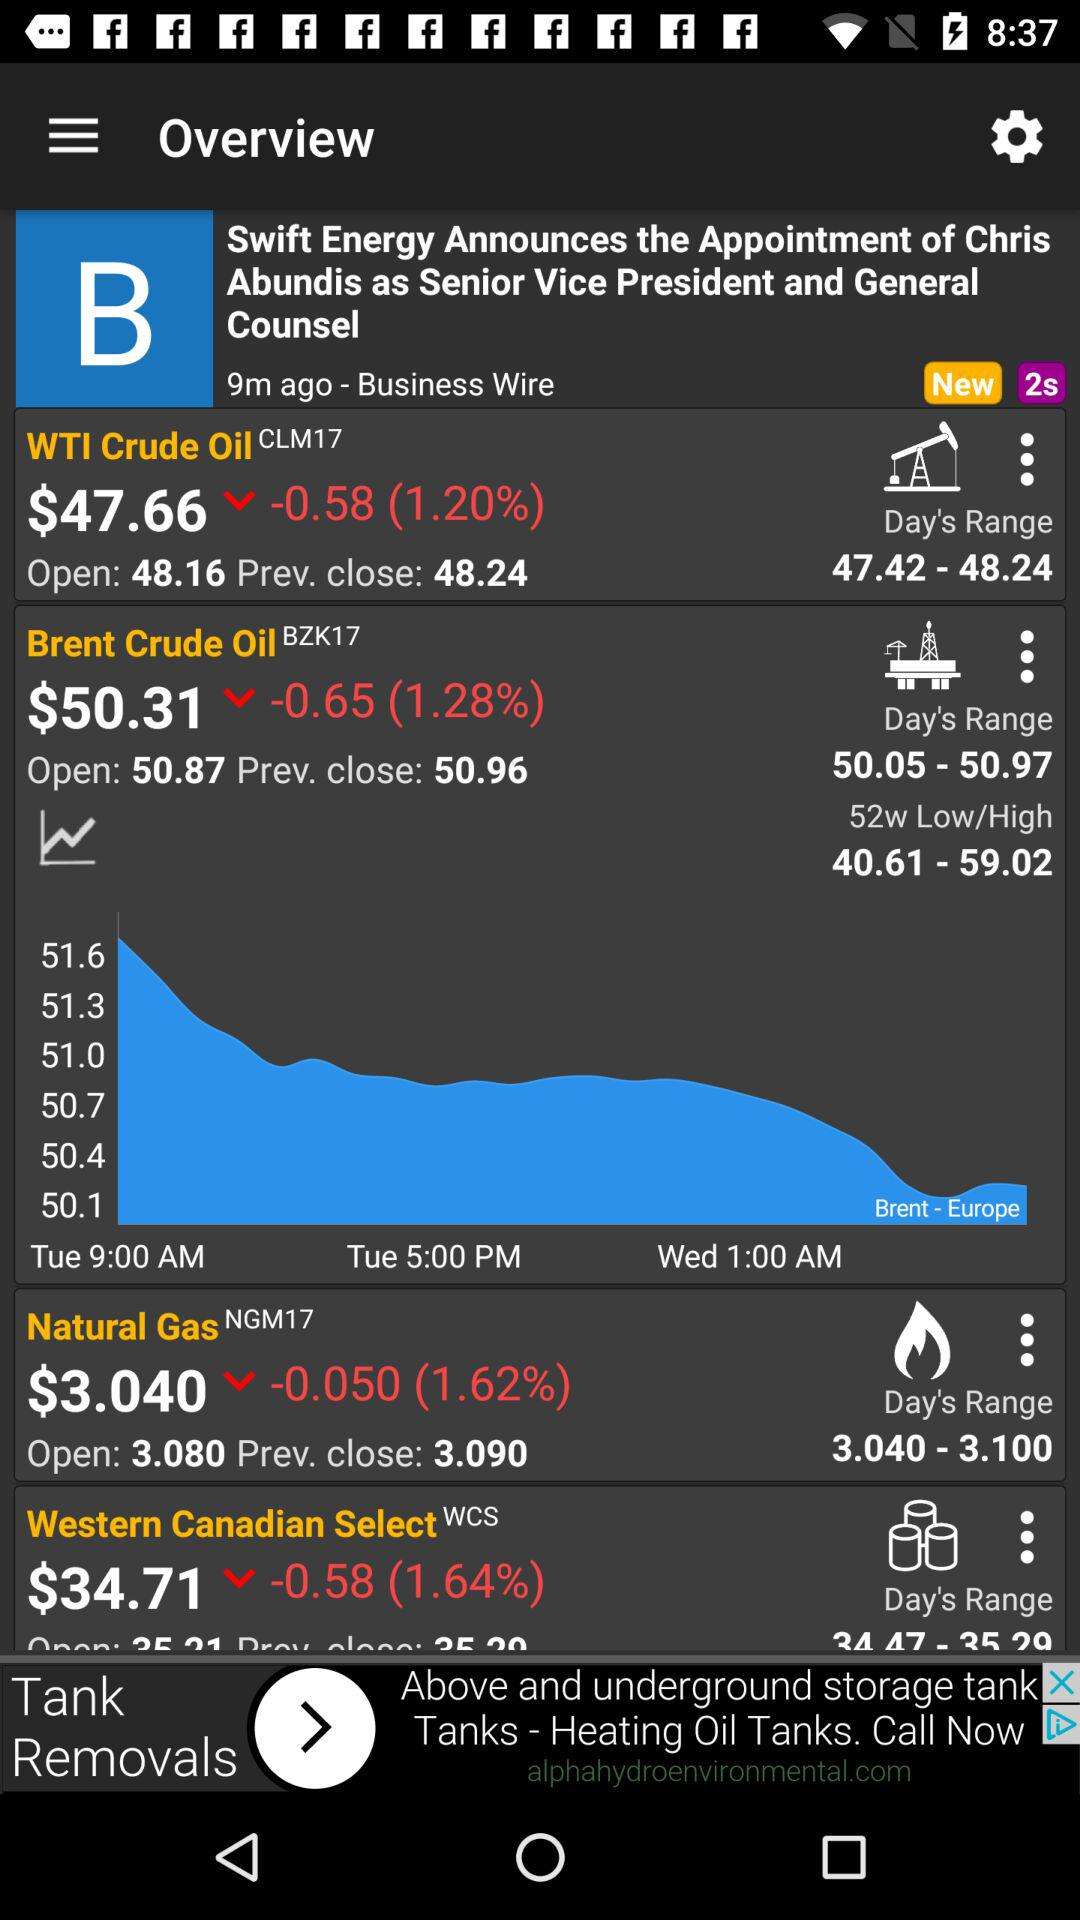What is the day's range of "Natural Gas"? The day's range of "Natural Gas" is between 3.040 and 3.100. 